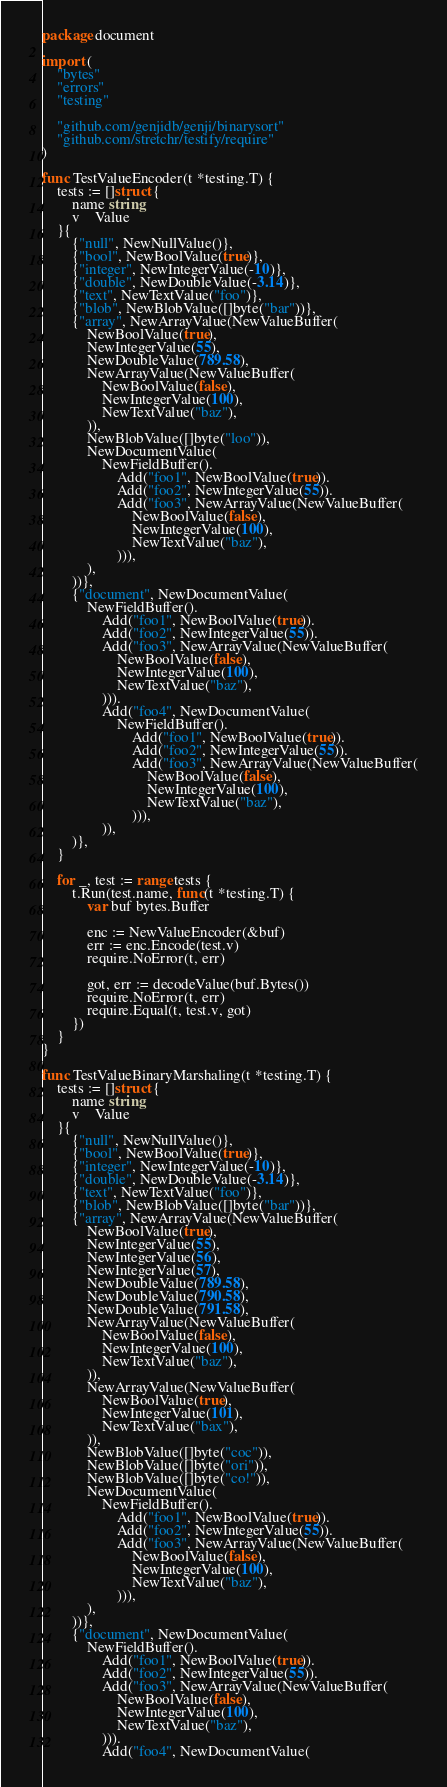Convert code to text. <code><loc_0><loc_0><loc_500><loc_500><_Go_>package document

import (
	"bytes"
	"errors"
	"testing"

	"github.com/genjidb/genji/binarysort"
	"github.com/stretchr/testify/require"
)

func TestValueEncoder(t *testing.T) {
	tests := []struct {
		name string
		v    Value
	}{
		{"null", NewNullValue()},
		{"bool", NewBoolValue(true)},
		{"integer", NewIntegerValue(-10)},
		{"double", NewDoubleValue(-3.14)},
		{"text", NewTextValue("foo")},
		{"blob", NewBlobValue([]byte("bar"))},
		{"array", NewArrayValue(NewValueBuffer(
			NewBoolValue(true),
			NewIntegerValue(55),
			NewDoubleValue(789.58),
			NewArrayValue(NewValueBuffer(
				NewBoolValue(false),
				NewIntegerValue(100),
				NewTextValue("baz"),
			)),
			NewBlobValue([]byte("loo")),
			NewDocumentValue(
				NewFieldBuffer().
					Add("foo1", NewBoolValue(true)).
					Add("foo2", NewIntegerValue(55)).
					Add("foo3", NewArrayValue(NewValueBuffer(
						NewBoolValue(false),
						NewIntegerValue(100),
						NewTextValue("baz"),
					))),
			),
		))},
		{"document", NewDocumentValue(
			NewFieldBuffer().
				Add("foo1", NewBoolValue(true)).
				Add("foo2", NewIntegerValue(55)).
				Add("foo3", NewArrayValue(NewValueBuffer(
					NewBoolValue(false),
					NewIntegerValue(100),
					NewTextValue("baz"),
				))).
				Add("foo4", NewDocumentValue(
					NewFieldBuffer().
						Add("foo1", NewBoolValue(true)).
						Add("foo2", NewIntegerValue(55)).
						Add("foo3", NewArrayValue(NewValueBuffer(
							NewBoolValue(false),
							NewIntegerValue(100),
							NewTextValue("baz"),
						))),
				)),
		)},
	}

	for _, test := range tests {
		t.Run(test.name, func(t *testing.T) {
			var buf bytes.Buffer

			enc := NewValueEncoder(&buf)
			err := enc.Encode(test.v)
			require.NoError(t, err)

			got, err := decodeValue(buf.Bytes())
			require.NoError(t, err)
			require.Equal(t, test.v, got)
		})
	}
}

func TestValueBinaryMarshaling(t *testing.T) {
	tests := []struct {
		name string
		v    Value
	}{
		{"null", NewNullValue()},
		{"bool", NewBoolValue(true)},
		{"integer", NewIntegerValue(-10)},
		{"double", NewDoubleValue(-3.14)},
		{"text", NewTextValue("foo")},
		{"blob", NewBlobValue([]byte("bar"))},
		{"array", NewArrayValue(NewValueBuffer(
			NewBoolValue(true),
			NewIntegerValue(55),
			NewIntegerValue(56),
			NewIntegerValue(57),
			NewDoubleValue(789.58),
			NewDoubleValue(790.58),
			NewDoubleValue(791.58),
			NewArrayValue(NewValueBuffer(
				NewBoolValue(false),
				NewIntegerValue(100),
				NewTextValue("baz"),
			)),
			NewArrayValue(NewValueBuffer(
				NewBoolValue(true),
				NewIntegerValue(101),
				NewTextValue("bax"),
			)),
			NewBlobValue([]byte("coc")),
			NewBlobValue([]byte("ori")),
			NewBlobValue([]byte("co!")),
			NewDocumentValue(
				NewFieldBuffer().
					Add("foo1", NewBoolValue(true)).
					Add("foo2", NewIntegerValue(55)).
					Add("foo3", NewArrayValue(NewValueBuffer(
						NewBoolValue(false),
						NewIntegerValue(100),
						NewTextValue("baz"),
					))),
			),
		))},
		{"document", NewDocumentValue(
			NewFieldBuffer().
				Add("foo1", NewBoolValue(true)).
				Add("foo2", NewIntegerValue(55)).
				Add("foo3", NewArrayValue(NewValueBuffer(
					NewBoolValue(false),
					NewIntegerValue(100),
					NewTextValue("baz"),
				))).
				Add("foo4", NewDocumentValue(</code> 